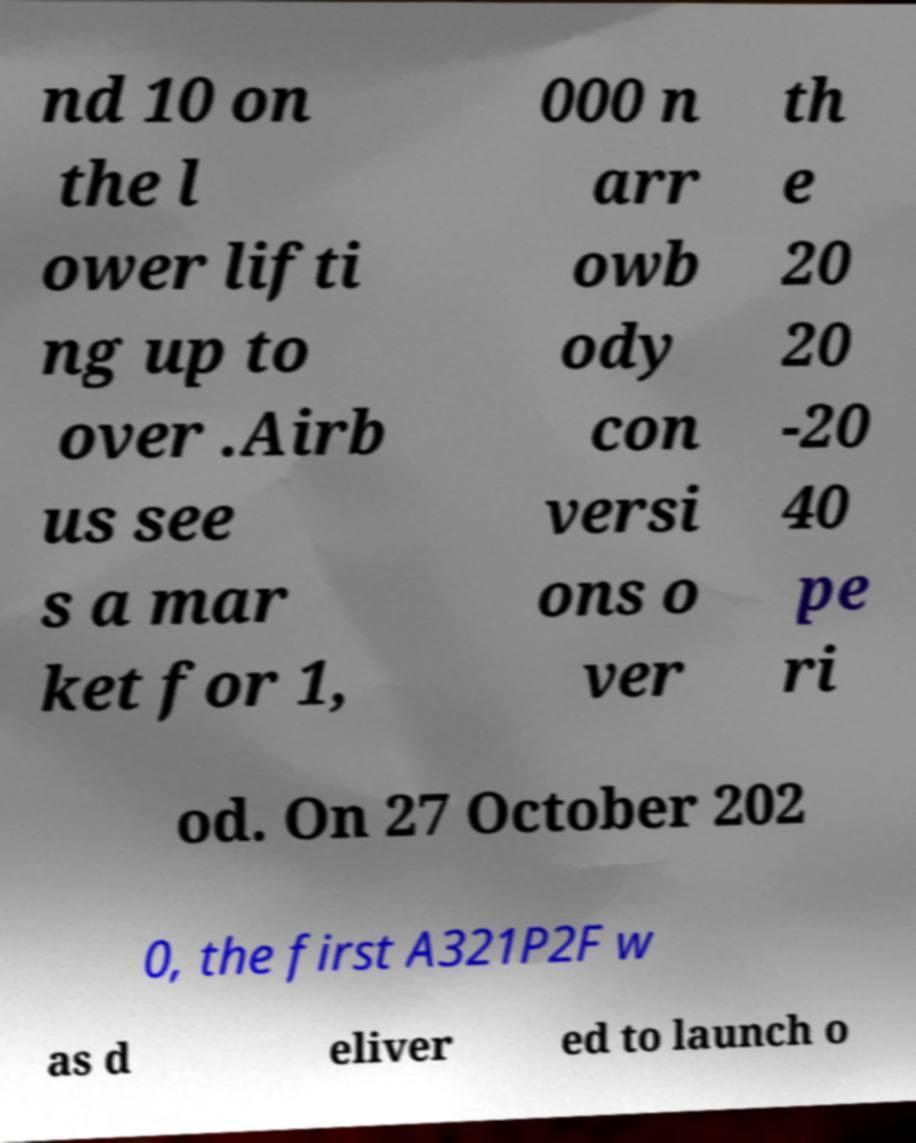What messages or text are displayed in this image? I need them in a readable, typed format. nd 10 on the l ower lifti ng up to over .Airb us see s a mar ket for 1, 000 n arr owb ody con versi ons o ver th e 20 20 -20 40 pe ri od. On 27 October 202 0, the first A321P2F w as d eliver ed to launch o 